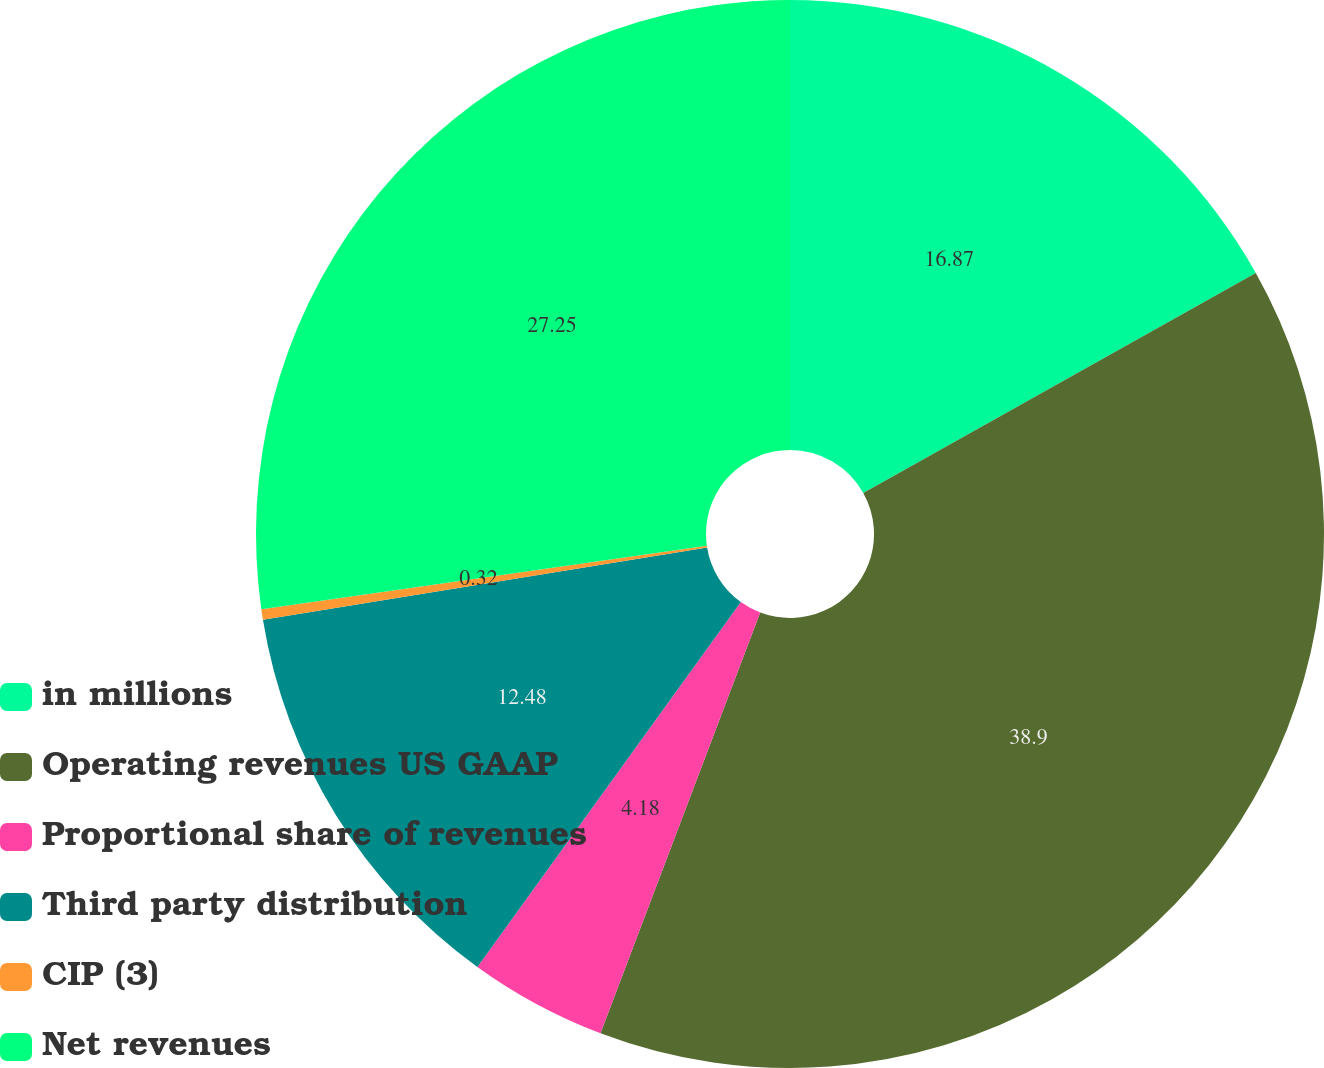<chart> <loc_0><loc_0><loc_500><loc_500><pie_chart><fcel>in millions<fcel>Operating revenues US GAAP<fcel>Proportional share of revenues<fcel>Third party distribution<fcel>CIP (3)<fcel>Net revenues<nl><fcel>16.87%<fcel>38.91%<fcel>4.18%<fcel>12.48%<fcel>0.32%<fcel>27.25%<nl></chart> 